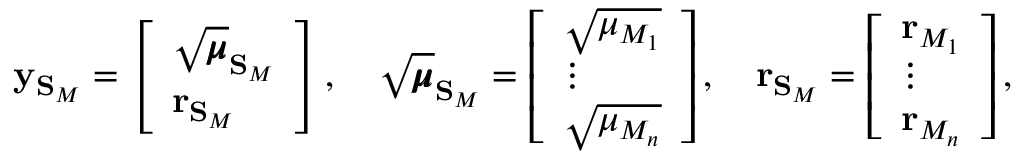<formula> <loc_0><loc_0><loc_500><loc_500>y _ { S _ { M } } = \left [ \begin{array} { l } { \sqrt { \pm b { \mu } } _ { S _ { M } } } \\ { r _ { S _ { M } } } \end{array} \right ] , \quad \sqrt { \pm b { \mu } } _ { S _ { M } } = \left [ \begin{array} { l } { \sqrt { \mu _ { M _ { 1 } } } } \\ { \vdots } \\ { \sqrt { \mu _ { M _ { n } } } } \end{array} \right ] , \quad r _ { S _ { M } } = \left [ \begin{array} { l } { r _ { M _ { 1 } } } \\ { \vdots } \\ { r _ { M _ { n } } } \end{array} \right ] ,</formula> 